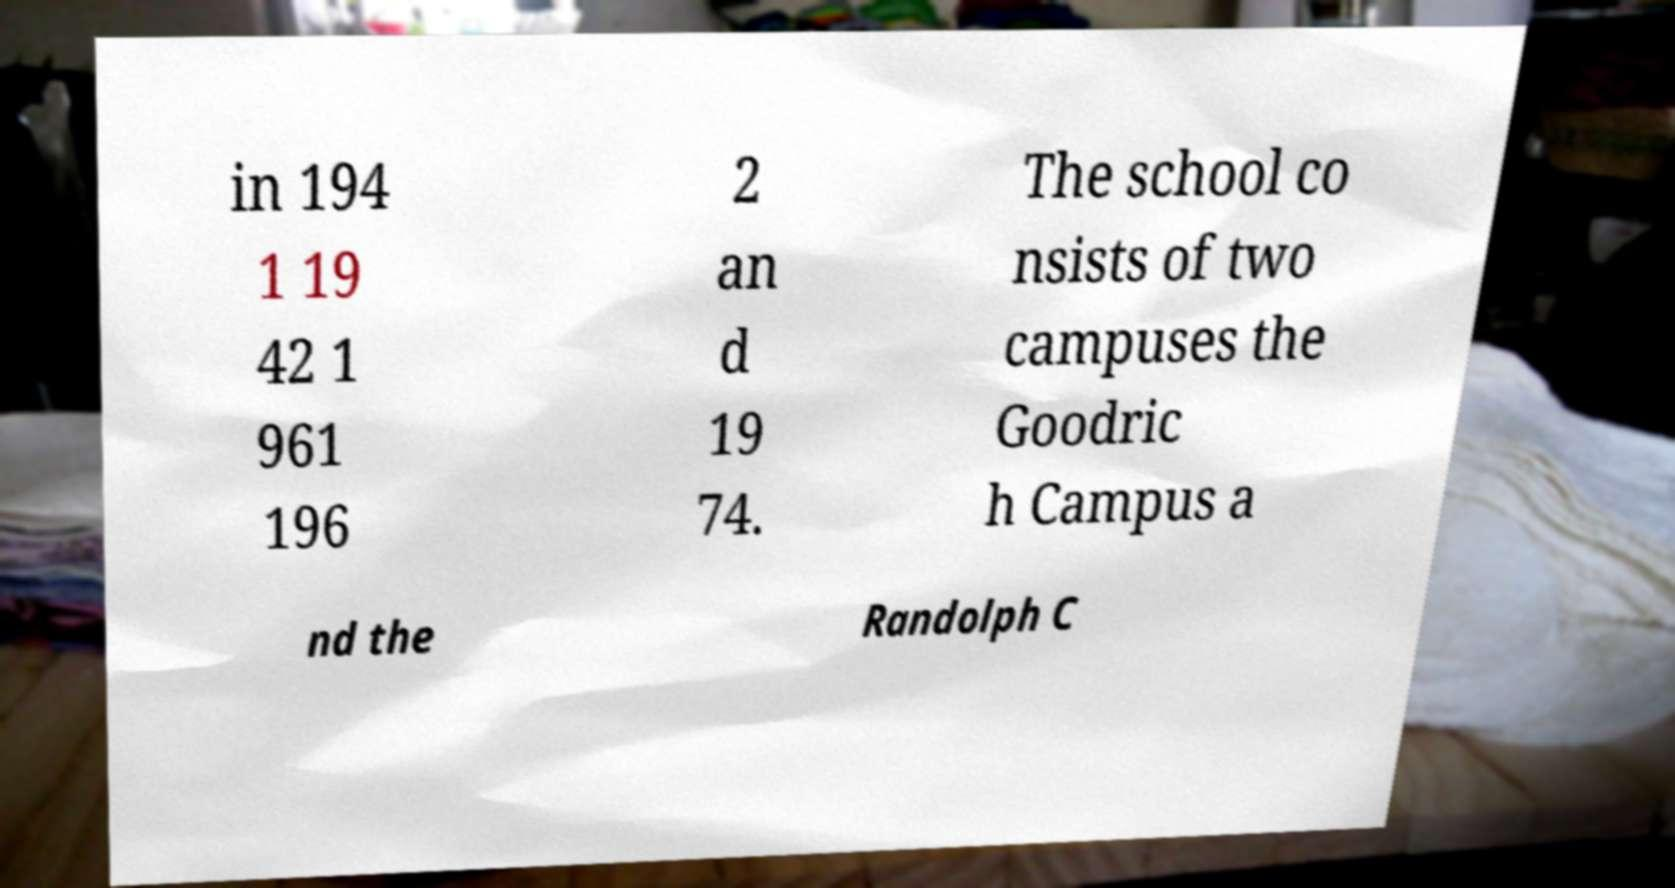Could you assist in decoding the text presented in this image and type it out clearly? in 194 1 19 42 1 961 196 2 an d 19 74. The school co nsists of two campuses the Goodric h Campus a nd the Randolph C 